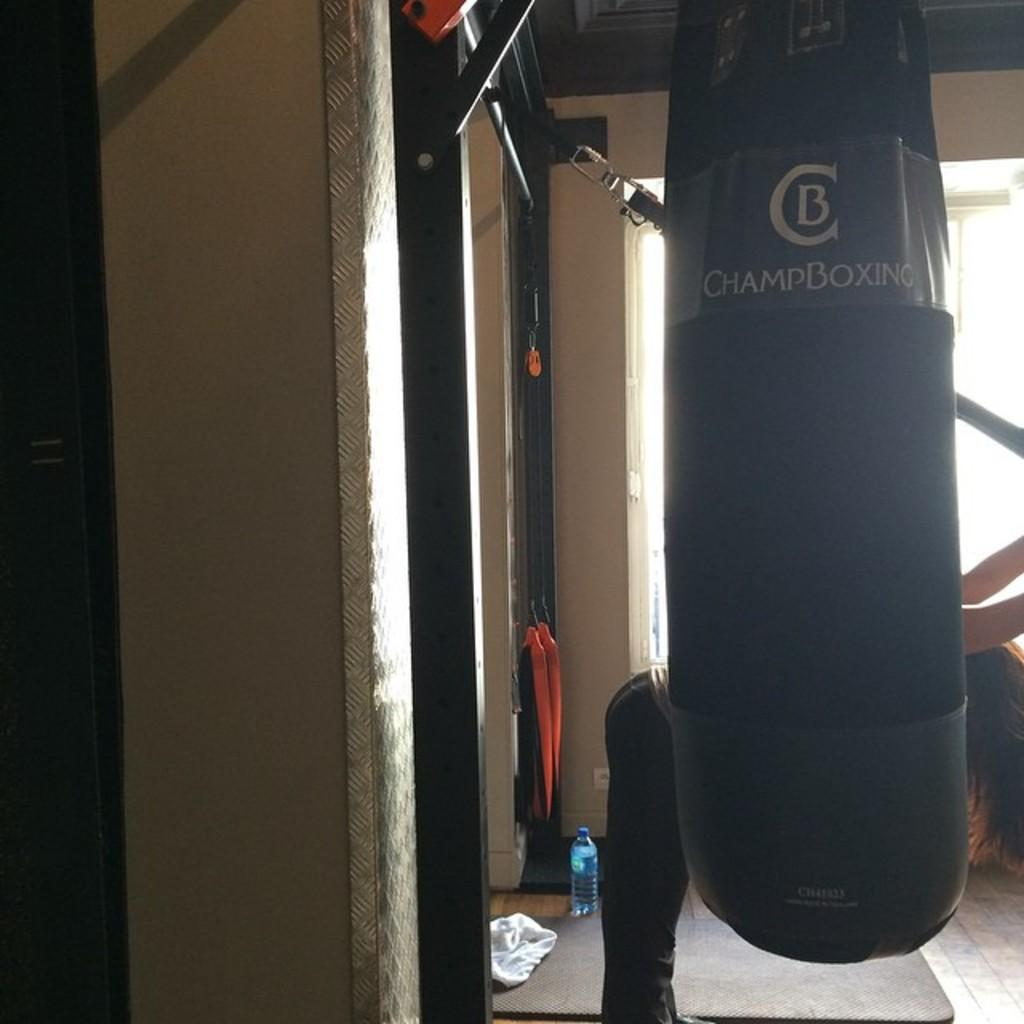What object can be seen in the image that might be used for carrying items? There is a bag in the image that might be used for carrying items. What part of a person can be seen in the image? A person's leg is visible in the image. What object is on the floor in the image? There is a bottle on the floor in the image. What type of surface is visible in the image? The wall is visible in the image. What long, thin object is visible in the image? A rod is visible in the image. What type of quilt is being used to destroy the wall in the image? There is no quilt or destruction present in the image. How many arms are visible in the image? There is no arm visible in the image; only a person's leg is visible. 